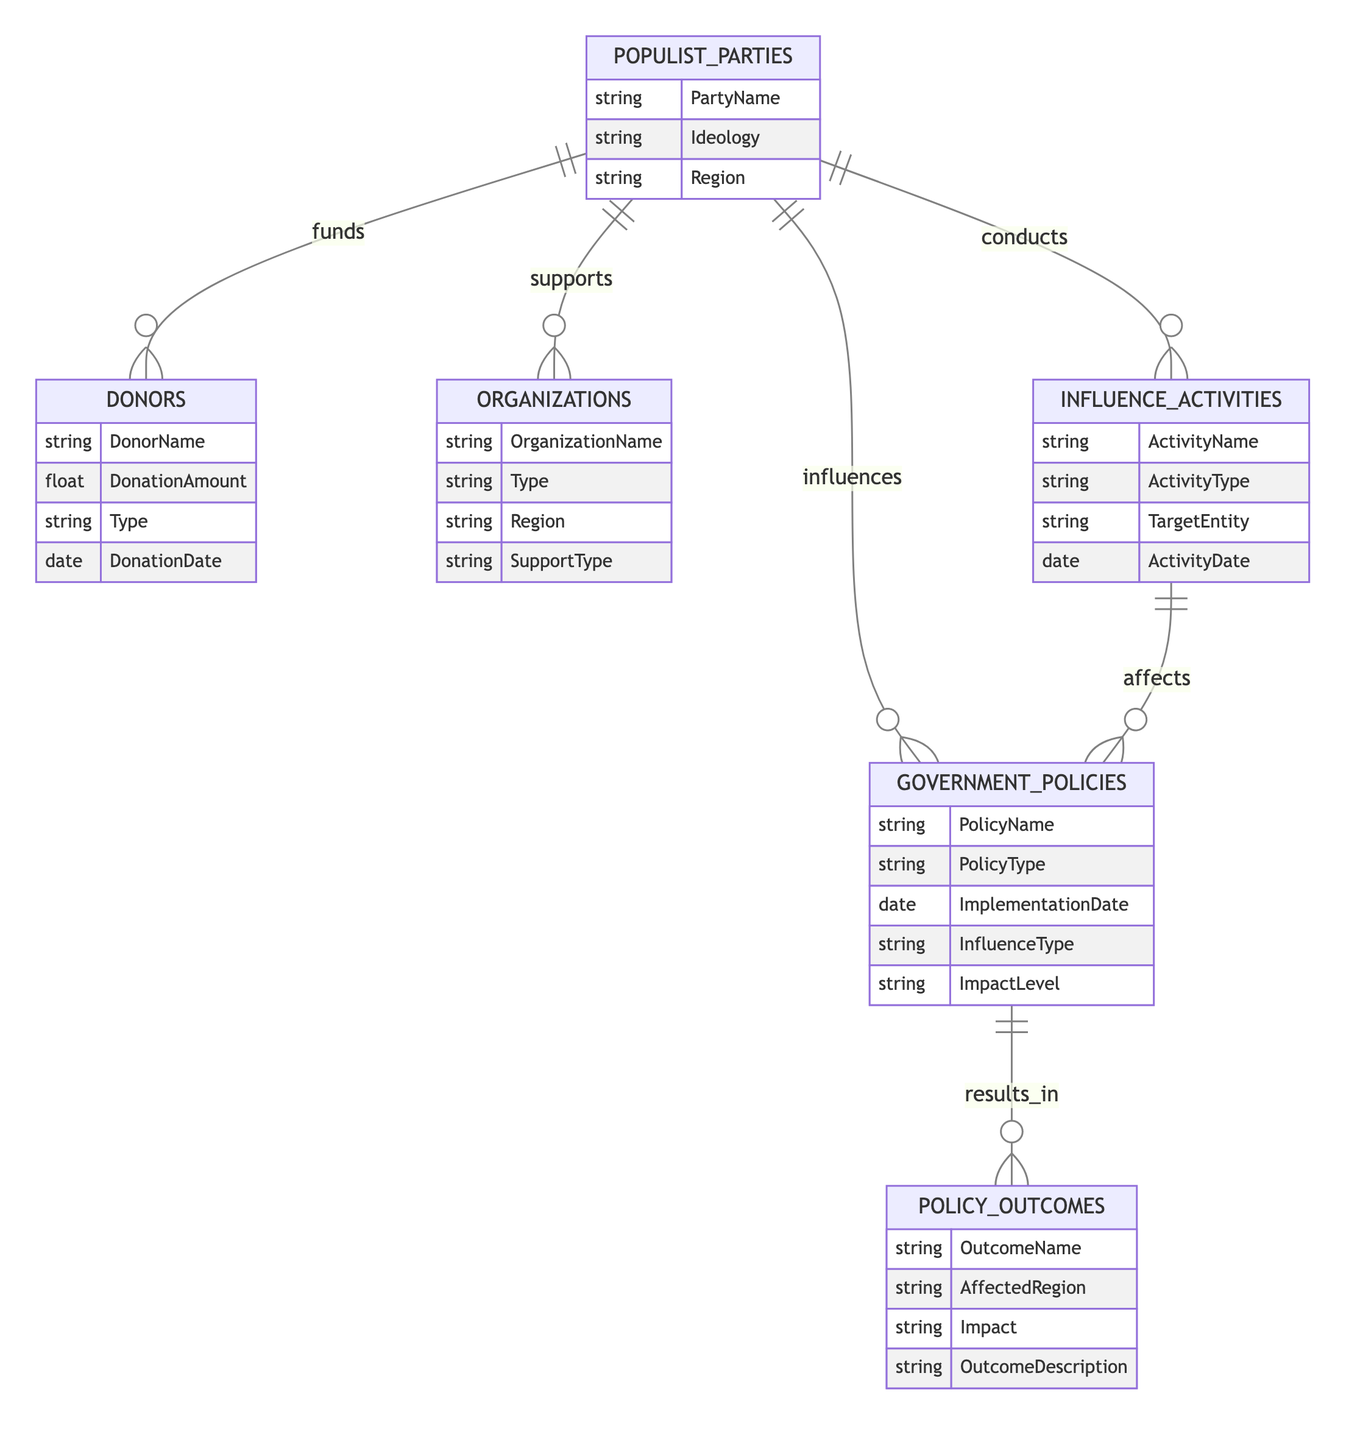What entities are present in the diagram? The entities visible in the diagram include Populist Parties, Donors, Organizations, Influence Activities, Government Policies, and Policy Outcomes. These represent the different components involved in the relationships concerning populist party funding and political influence.
Answer: Populist Parties, Donors, Organizations, Influence Activities, Government Policies, Policy Outcomes How many relationships are depicted in the diagram? By counting the connections in the relationships section, we find there are six relationships: funds, supports, conducts, influences, results in, and affects. This indicates the various ways entities interact with one another.
Answer: 6 Which entity conducts Influence Activities? Looking at the relationships, Populist Parties are identified as the entities that conduct Influence Activities. They initiate actions aimed at affecting other elements in the political landscape such as policies.
Answer: Populist Parties What type of relationship is between Government Policies and Policy Outcomes? The relationship between Government Policies and Policy Outcomes is described as "results in," indicating that specific government policies lead directly to certain outcomes that affect regions.
Answer: results in Which entity supports Populist Parties? The diagram specifies that Organizations play a supporting role to Populist Parties, indicating a collaborative relationship where organizations may provide resources or backing for their initiatives.
Answer: Organizations What is the impact of Influence Activities on Government Policies? The Influence Activities affect Government Policies, indicating that the conducted activities by populist parties have the potential to change or influence the nature of policies implemented by the government.
Answer: affects What do Donors provide to Populist Parties? Donors provide monetary contributions labeled as "DonationAmount," reflecting the financial backing that populist parties receive from various donors as part of their funding sources.
Answer: DonationAmount How are Policies influenced by Populist Parties? The relationship established in the diagram notes that Populist Parties influence Government Policies through a direct link, with a specified attribute of "InfluenceType" clarifying the manner of influence.
Answer: influences What is the significance of the 'DonationDate' attribute in the Donors entity? The 'DonationDate' attribute records the timing of donations made to the Populist Parties, providing insights into the temporal dynamics of financial contributions and potentially correlating them with political activities or events.
Answer: DonationDate 